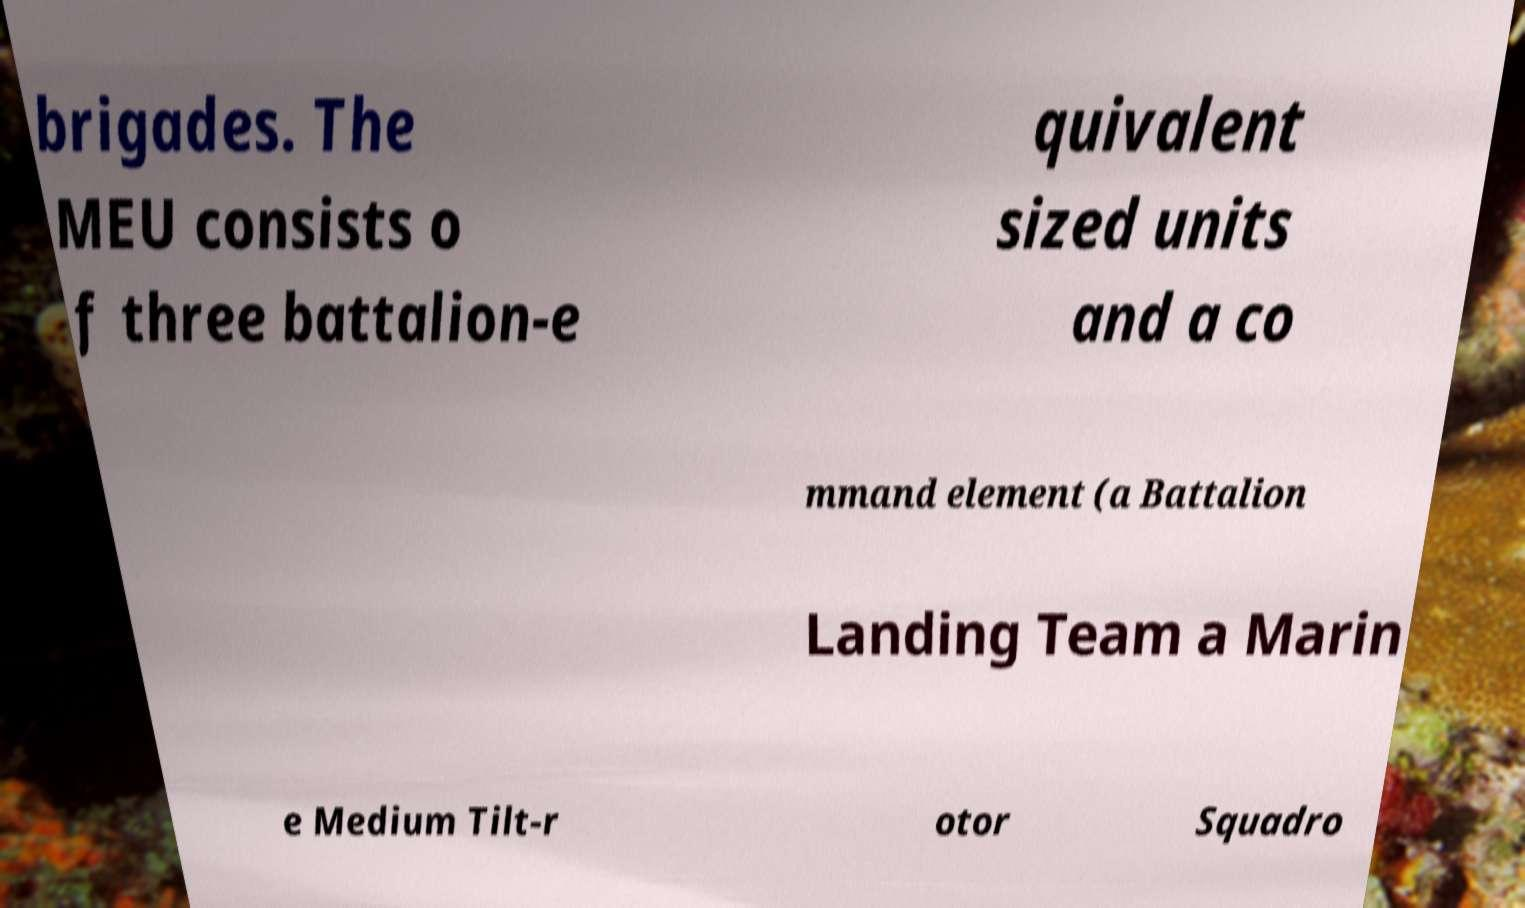Could you assist in decoding the text presented in this image and type it out clearly? brigades. The MEU consists o f three battalion-e quivalent sized units and a co mmand element (a Battalion Landing Team a Marin e Medium Tilt-r otor Squadro 